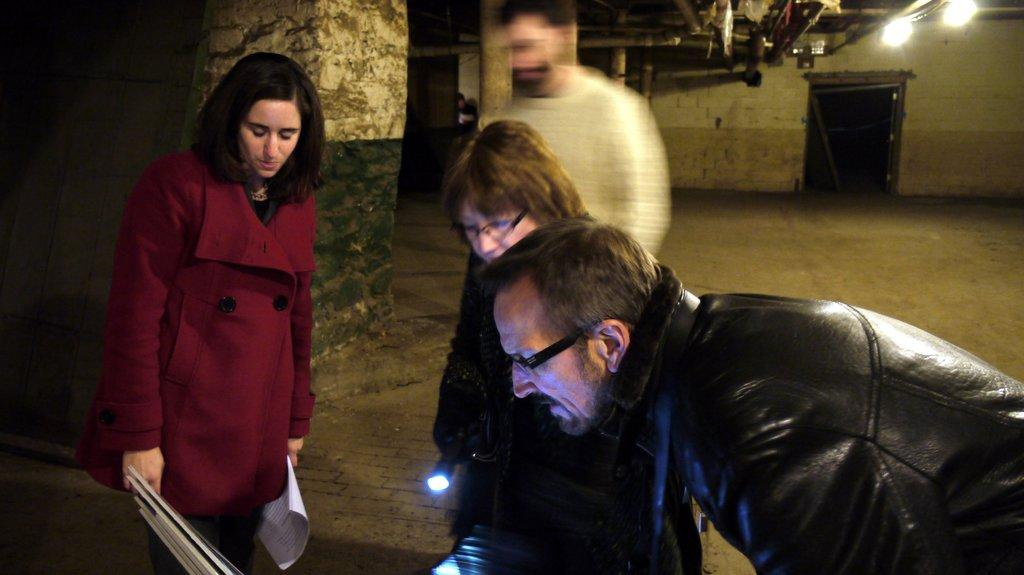What can be seen in the image? There are people standing in the image. What object is visible that can provide light? There is a torch light visible in the image. What is in the background of the image? There is a wall in the background of the image. What type of body is present in the image? There is no body present in the image; only people standing and a torch light are visible. Can you see any twigs in the image? There are no twigs present in the image. 